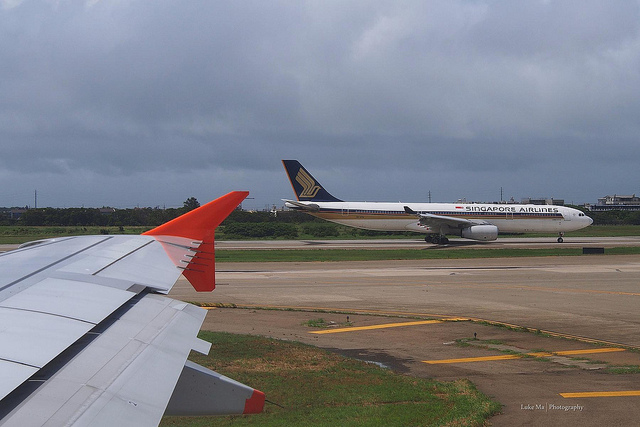Please transcribe the text information in this image. SInGAPORE AIRLINES Lake Ma Photograhy 